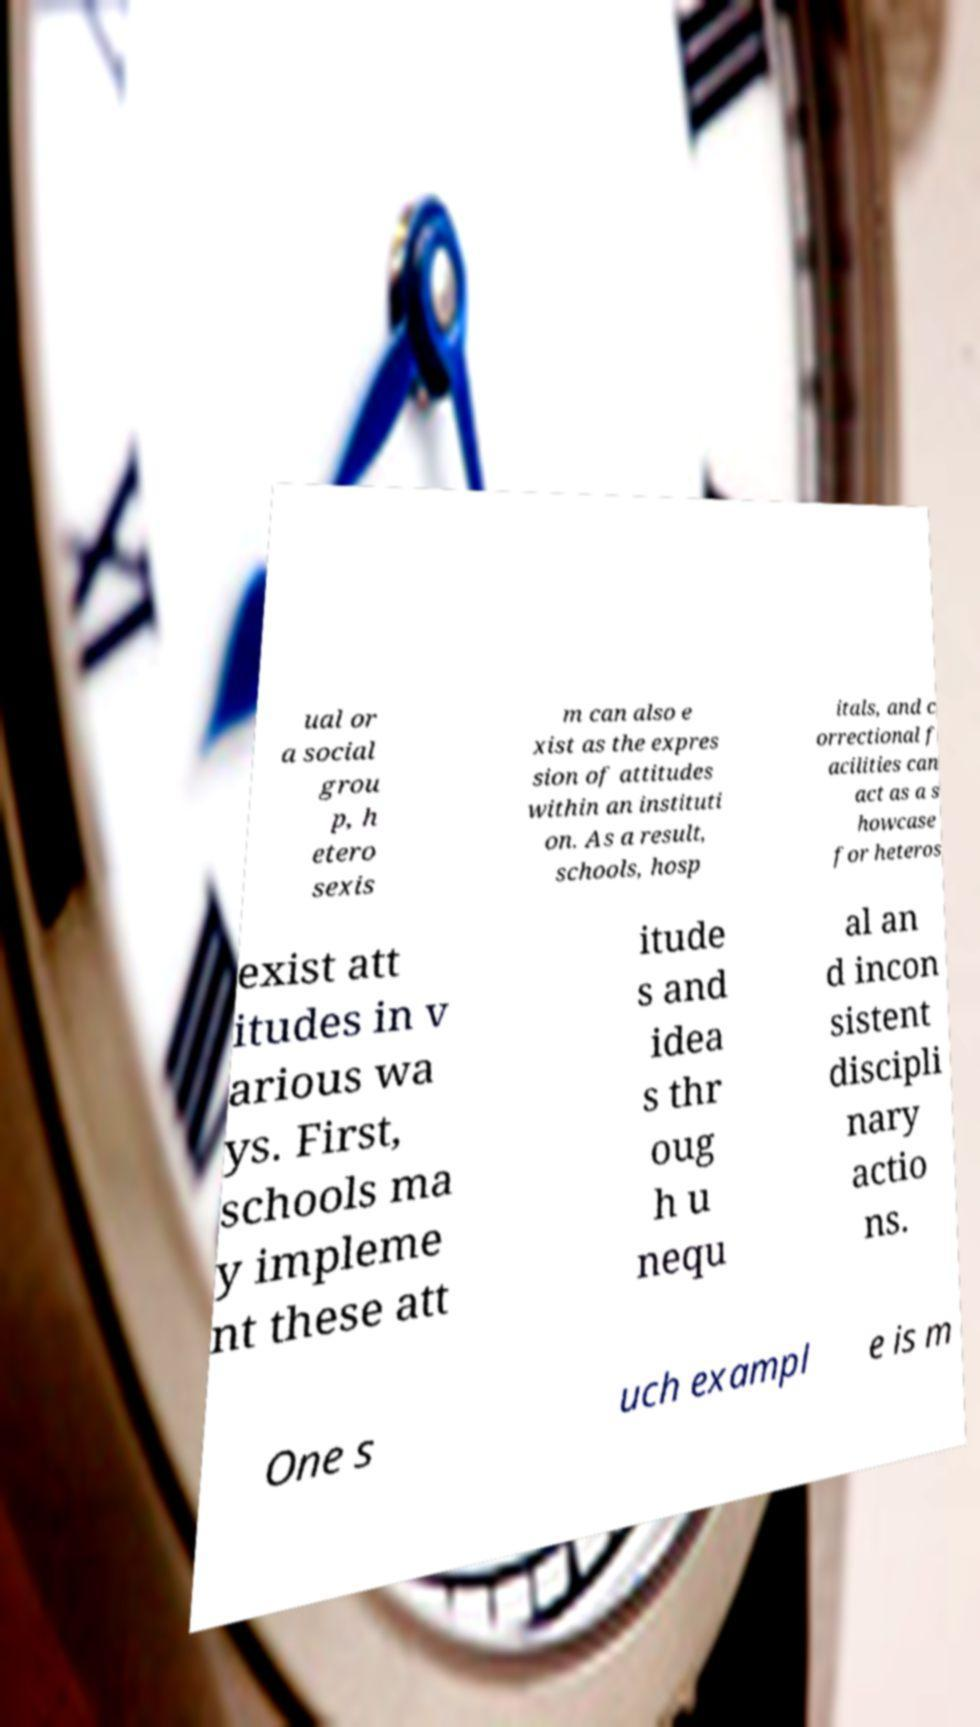What messages or text are displayed in this image? I need them in a readable, typed format. ual or a social grou p, h etero sexis m can also e xist as the expres sion of attitudes within an instituti on. As a result, schools, hosp itals, and c orrectional f acilities can act as a s howcase for heteros exist att itudes in v arious wa ys. First, schools ma y impleme nt these att itude s and idea s thr oug h u nequ al an d incon sistent discipli nary actio ns. One s uch exampl e is m 